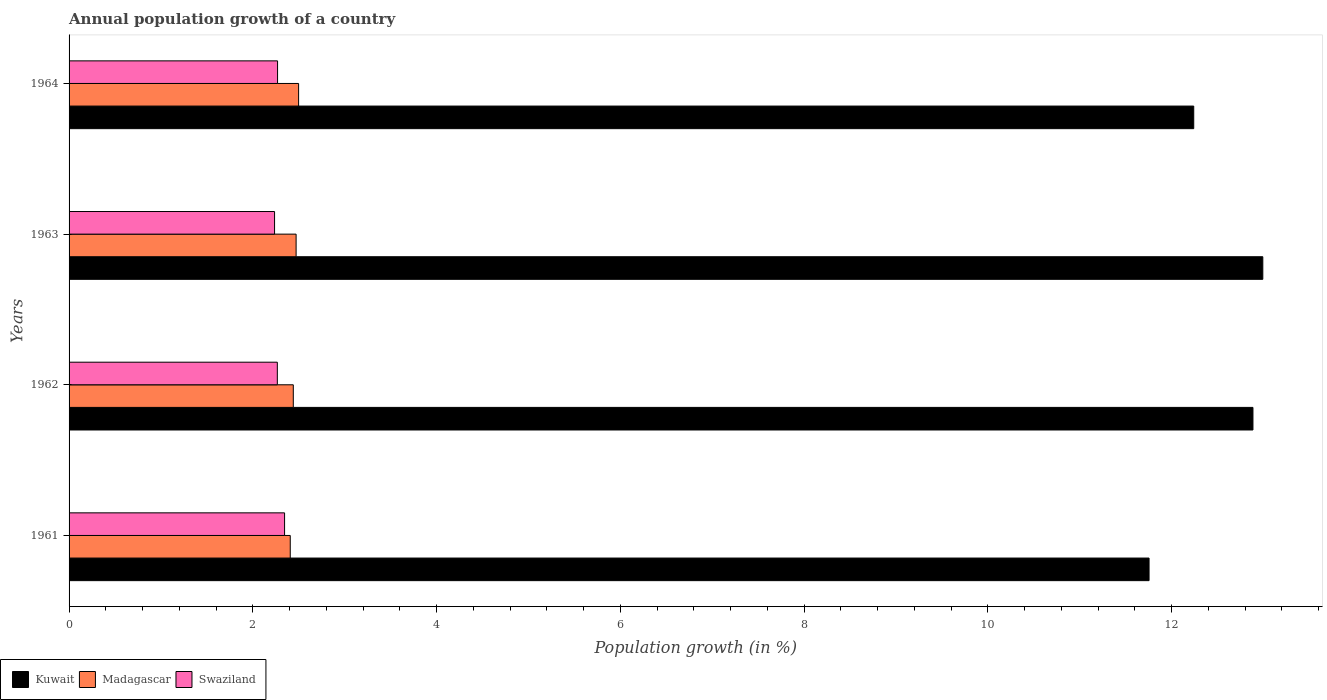Are the number of bars on each tick of the Y-axis equal?
Ensure brevity in your answer.  Yes. How many bars are there on the 3rd tick from the top?
Your response must be concise. 3. What is the label of the 4th group of bars from the top?
Provide a succinct answer. 1961. What is the annual population growth in Kuwait in 1963?
Give a very brief answer. 12.99. Across all years, what is the maximum annual population growth in Swaziland?
Make the answer very short. 2.35. Across all years, what is the minimum annual population growth in Kuwait?
Your answer should be compact. 11.76. In which year was the annual population growth in Kuwait maximum?
Provide a succinct answer. 1963. In which year was the annual population growth in Kuwait minimum?
Your answer should be compact. 1961. What is the total annual population growth in Kuwait in the graph?
Offer a very short reply. 49.88. What is the difference between the annual population growth in Kuwait in 1962 and that in 1963?
Offer a terse response. -0.11. What is the difference between the annual population growth in Kuwait in 1964 and the annual population growth in Madagascar in 1963?
Keep it short and to the point. 9.77. What is the average annual population growth in Kuwait per year?
Your answer should be very brief. 12.47. In the year 1963, what is the difference between the annual population growth in Kuwait and annual population growth in Swaziland?
Your answer should be compact. 10.76. What is the ratio of the annual population growth in Swaziland in 1962 to that in 1964?
Give a very brief answer. 1. Is the annual population growth in Madagascar in 1961 less than that in 1963?
Offer a very short reply. Yes. Is the difference between the annual population growth in Kuwait in 1962 and 1964 greater than the difference between the annual population growth in Swaziland in 1962 and 1964?
Your answer should be compact. Yes. What is the difference between the highest and the second highest annual population growth in Kuwait?
Give a very brief answer. 0.11. What is the difference between the highest and the lowest annual population growth in Madagascar?
Keep it short and to the point. 0.09. Is the sum of the annual population growth in Swaziland in 1962 and 1964 greater than the maximum annual population growth in Kuwait across all years?
Give a very brief answer. No. What does the 1st bar from the top in 1964 represents?
Ensure brevity in your answer.  Swaziland. What does the 3rd bar from the bottom in 1962 represents?
Offer a terse response. Swaziland. Is it the case that in every year, the sum of the annual population growth in Kuwait and annual population growth in Swaziland is greater than the annual population growth in Madagascar?
Provide a short and direct response. Yes. How many bars are there?
Offer a very short reply. 12. How many years are there in the graph?
Keep it short and to the point. 4. Does the graph contain grids?
Provide a short and direct response. No. How are the legend labels stacked?
Keep it short and to the point. Horizontal. What is the title of the graph?
Your answer should be very brief. Annual population growth of a country. What is the label or title of the X-axis?
Ensure brevity in your answer.  Population growth (in %). What is the Population growth (in %) of Kuwait in 1961?
Make the answer very short. 11.76. What is the Population growth (in %) in Madagascar in 1961?
Your answer should be compact. 2.41. What is the Population growth (in %) in Swaziland in 1961?
Offer a terse response. 2.35. What is the Population growth (in %) of Kuwait in 1962?
Make the answer very short. 12.89. What is the Population growth (in %) in Madagascar in 1962?
Your answer should be compact. 2.44. What is the Population growth (in %) of Swaziland in 1962?
Offer a terse response. 2.27. What is the Population growth (in %) of Kuwait in 1963?
Give a very brief answer. 12.99. What is the Population growth (in %) in Madagascar in 1963?
Provide a short and direct response. 2.47. What is the Population growth (in %) in Swaziland in 1963?
Provide a succinct answer. 2.24. What is the Population growth (in %) of Kuwait in 1964?
Offer a very short reply. 12.24. What is the Population growth (in %) of Madagascar in 1964?
Make the answer very short. 2.5. What is the Population growth (in %) in Swaziland in 1964?
Make the answer very short. 2.27. Across all years, what is the maximum Population growth (in %) of Kuwait?
Your response must be concise. 12.99. Across all years, what is the maximum Population growth (in %) in Madagascar?
Your answer should be very brief. 2.5. Across all years, what is the maximum Population growth (in %) in Swaziland?
Offer a very short reply. 2.35. Across all years, what is the minimum Population growth (in %) in Kuwait?
Your answer should be compact. 11.76. Across all years, what is the minimum Population growth (in %) in Madagascar?
Your answer should be very brief. 2.41. Across all years, what is the minimum Population growth (in %) of Swaziland?
Provide a succinct answer. 2.24. What is the total Population growth (in %) of Kuwait in the graph?
Provide a short and direct response. 49.88. What is the total Population growth (in %) in Madagascar in the graph?
Provide a succinct answer. 9.82. What is the total Population growth (in %) in Swaziland in the graph?
Your answer should be very brief. 9.12. What is the difference between the Population growth (in %) in Kuwait in 1961 and that in 1962?
Provide a succinct answer. -1.13. What is the difference between the Population growth (in %) in Madagascar in 1961 and that in 1962?
Ensure brevity in your answer.  -0.03. What is the difference between the Population growth (in %) of Swaziland in 1961 and that in 1962?
Offer a terse response. 0.08. What is the difference between the Population growth (in %) in Kuwait in 1961 and that in 1963?
Offer a very short reply. -1.24. What is the difference between the Population growth (in %) of Madagascar in 1961 and that in 1963?
Give a very brief answer. -0.06. What is the difference between the Population growth (in %) of Swaziland in 1961 and that in 1963?
Give a very brief answer. 0.11. What is the difference between the Population growth (in %) of Kuwait in 1961 and that in 1964?
Offer a terse response. -0.49. What is the difference between the Population growth (in %) of Madagascar in 1961 and that in 1964?
Provide a succinct answer. -0.09. What is the difference between the Population growth (in %) in Swaziland in 1961 and that in 1964?
Give a very brief answer. 0.08. What is the difference between the Population growth (in %) in Kuwait in 1962 and that in 1963?
Provide a short and direct response. -0.11. What is the difference between the Population growth (in %) in Madagascar in 1962 and that in 1963?
Your answer should be compact. -0.03. What is the difference between the Population growth (in %) of Swaziland in 1962 and that in 1963?
Ensure brevity in your answer.  0.03. What is the difference between the Population growth (in %) in Kuwait in 1962 and that in 1964?
Offer a very short reply. 0.64. What is the difference between the Population growth (in %) in Madagascar in 1962 and that in 1964?
Your response must be concise. -0.06. What is the difference between the Population growth (in %) in Swaziland in 1962 and that in 1964?
Ensure brevity in your answer.  -0. What is the difference between the Population growth (in %) of Kuwait in 1963 and that in 1964?
Your answer should be compact. 0.75. What is the difference between the Population growth (in %) in Madagascar in 1963 and that in 1964?
Ensure brevity in your answer.  -0.03. What is the difference between the Population growth (in %) in Swaziland in 1963 and that in 1964?
Offer a terse response. -0.03. What is the difference between the Population growth (in %) in Kuwait in 1961 and the Population growth (in %) in Madagascar in 1962?
Provide a succinct answer. 9.31. What is the difference between the Population growth (in %) of Kuwait in 1961 and the Population growth (in %) of Swaziland in 1962?
Your response must be concise. 9.49. What is the difference between the Population growth (in %) in Madagascar in 1961 and the Population growth (in %) in Swaziland in 1962?
Provide a succinct answer. 0.14. What is the difference between the Population growth (in %) in Kuwait in 1961 and the Population growth (in %) in Madagascar in 1963?
Provide a succinct answer. 9.28. What is the difference between the Population growth (in %) in Kuwait in 1961 and the Population growth (in %) in Swaziland in 1963?
Your response must be concise. 9.52. What is the difference between the Population growth (in %) in Madagascar in 1961 and the Population growth (in %) in Swaziland in 1963?
Give a very brief answer. 0.17. What is the difference between the Population growth (in %) of Kuwait in 1961 and the Population growth (in %) of Madagascar in 1964?
Keep it short and to the point. 9.26. What is the difference between the Population growth (in %) of Kuwait in 1961 and the Population growth (in %) of Swaziland in 1964?
Ensure brevity in your answer.  9.49. What is the difference between the Population growth (in %) in Madagascar in 1961 and the Population growth (in %) in Swaziland in 1964?
Your answer should be very brief. 0.14. What is the difference between the Population growth (in %) in Kuwait in 1962 and the Population growth (in %) in Madagascar in 1963?
Offer a very short reply. 10.41. What is the difference between the Population growth (in %) in Kuwait in 1962 and the Population growth (in %) in Swaziland in 1963?
Make the answer very short. 10.65. What is the difference between the Population growth (in %) of Madagascar in 1962 and the Population growth (in %) of Swaziland in 1963?
Give a very brief answer. 0.2. What is the difference between the Population growth (in %) in Kuwait in 1962 and the Population growth (in %) in Madagascar in 1964?
Ensure brevity in your answer.  10.39. What is the difference between the Population growth (in %) in Kuwait in 1962 and the Population growth (in %) in Swaziland in 1964?
Offer a very short reply. 10.62. What is the difference between the Population growth (in %) of Madagascar in 1962 and the Population growth (in %) of Swaziland in 1964?
Provide a short and direct response. 0.17. What is the difference between the Population growth (in %) of Kuwait in 1963 and the Population growth (in %) of Madagascar in 1964?
Your answer should be compact. 10.49. What is the difference between the Population growth (in %) of Kuwait in 1963 and the Population growth (in %) of Swaziland in 1964?
Your answer should be compact. 10.72. What is the difference between the Population growth (in %) in Madagascar in 1963 and the Population growth (in %) in Swaziland in 1964?
Keep it short and to the point. 0.2. What is the average Population growth (in %) in Kuwait per year?
Keep it short and to the point. 12.47. What is the average Population growth (in %) in Madagascar per year?
Keep it short and to the point. 2.45. What is the average Population growth (in %) of Swaziland per year?
Your response must be concise. 2.28. In the year 1961, what is the difference between the Population growth (in %) in Kuwait and Population growth (in %) in Madagascar?
Your response must be concise. 9.35. In the year 1961, what is the difference between the Population growth (in %) in Kuwait and Population growth (in %) in Swaziland?
Give a very brief answer. 9.41. In the year 1961, what is the difference between the Population growth (in %) in Madagascar and Population growth (in %) in Swaziland?
Provide a succinct answer. 0.06. In the year 1962, what is the difference between the Population growth (in %) in Kuwait and Population growth (in %) in Madagascar?
Make the answer very short. 10.45. In the year 1962, what is the difference between the Population growth (in %) of Kuwait and Population growth (in %) of Swaziland?
Offer a very short reply. 10.62. In the year 1962, what is the difference between the Population growth (in %) in Madagascar and Population growth (in %) in Swaziland?
Your response must be concise. 0.17. In the year 1963, what is the difference between the Population growth (in %) of Kuwait and Population growth (in %) of Madagascar?
Make the answer very short. 10.52. In the year 1963, what is the difference between the Population growth (in %) in Kuwait and Population growth (in %) in Swaziland?
Your answer should be very brief. 10.76. In the year 1963, what is the difference between the Population growth (in %) of Madagascar and Population growth (in %) of Swaziland?
Your response must be concise. 0.23. In the year 1964, what is the difference between the Population growth (in %) in Kuwait and Population growth (in %) in Madagascar?
Keep it short and to the point. 9.74. In the year 1964, what is the difference between the Population growth (in %) in Kuwait and Population growth (in %) in Swaziland?
Provide a succinct answer. 9.97. In the year 1964, what is the difference between the Population growth (in %) of Madagascar and Population growth (in %) of Swaziland?
Provide a succinct answer. 0.23. What is the ratio of the Population growth (in %) of Kuwait in 1961 to that in 1962?
Give a very brief answer. 0.91. What is the ratio of the Population growth (in %) in Madagascar in 1961 to that in 1962?
Ensure brevity in your answer.  0.99. What is the ratio of the Population growth (in %) of Swaziland in 1961 to that in 1962?
Offer a terse response. 1.03. What is the ratio of the Population growth (in %) in Kuwait in 1961 to that in 1963?
Provide a succinct answer. 0.9. What is the ratio of the Population growth (in %) in Madagascar in 1961 to that in 1963?
Your response must be concise. 0.97. What is the ratio of the Population growth (in %) of Swaziland in 1961 to that in 1963?
Give a very brief answer. 1.05. What is the ratio of the Population growth (in %) of Kuwait in 1961 to that in 1964?
Keep it short and to the point. 0.96. What is the ratio of the Population growth (in %) in Madagascar in 1961 to that in 1964?
Offer a very short reply. 0.96. What is the ratio of the Population growth (in %) of Swaziland in 1961 to that in 1964?
Your answer should be compact. 1.03. What is the ratio of the Population growth (in %) in Madagascar in 1962 to that in 1963?
Provide a short and direct response. 0.99. What is the ratio of the Population growth (in %) in Swaziland in 1962 to that in 1963?
Your answer should be compact. 1.01. What is the ratio of the Population growth (in %) in Kuwait in 1962 to that in 1964?
Offer a terse response. 1.05. What is the ratio of the Population growth (in %) of Madagascar in 1962 to that in 1964?
Ensure brevity in your answer.  0.98. What is the ratio of the Population growth (in %) of Kuwait in 1963 to that in 1964?
Give a very brief answer. 1.06. What is the ratio of the Population growth (in %) in Madagascar in 1963 to that in 1964?
Make the answer very short. 0.99. What is the ratio of the Population growth (in %) in Swaziland in 1963 to that in 1964?
Your answer should be compact. 0.99. What is the difference between the highest and the second highest Population growth (in %) in Kuwait?
Your answer should be compact. 0.11. What is the difference between the highest and the second highest Population growth (in %) in Madagascar?
Your response must be concise. 0.03. What is the difference between the highest and the second highest Population growth (in %) in Swaziland?
Your response must be concise. 0.08. What is the difference between the highest and the lowest Population growth (in %) in Kuwait?
Provide a succinct answer. 1.24. What is the difference between the highest and the lowest Population growth (in %) of Madagascar?
Give a very brief answer. 0.09. What is the difference between the highest and the lowest Population growth (in %) in Swaziland?
Keep it short and to the point. 0.11. 